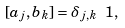Convert formula to latex. <formula><loc_0><loc_0><loc_500><loc_500>[ a _ { j } , b _ { k } ] = \delta _ { j , k } \ 1 ,</formula> 